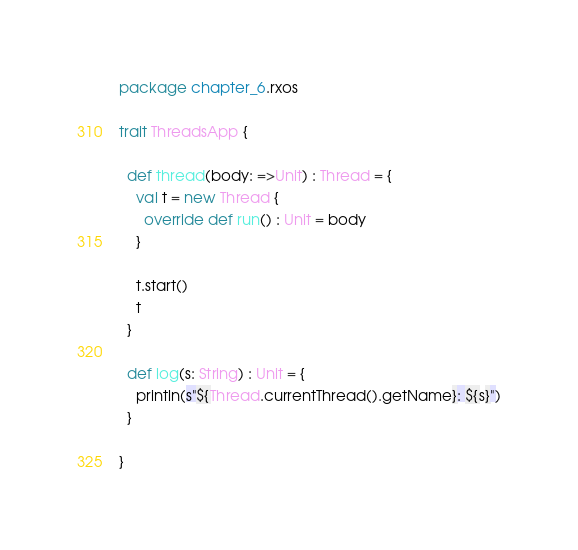<code> <loc_0><loc_0><loc_500><loc_500><_Scala_>package chapter_6.rxos

trait ThreadsApp {

  def thread(body: =>Unit) : Thread = {
    val t = new Thread {
      override def run() : Unit = body
    }

    t.start()
    t
  }

  def log(s: String) : Unit = {
    println(s"${Thread.currentThread().getName}: ${s}")
  }

}
</code> 